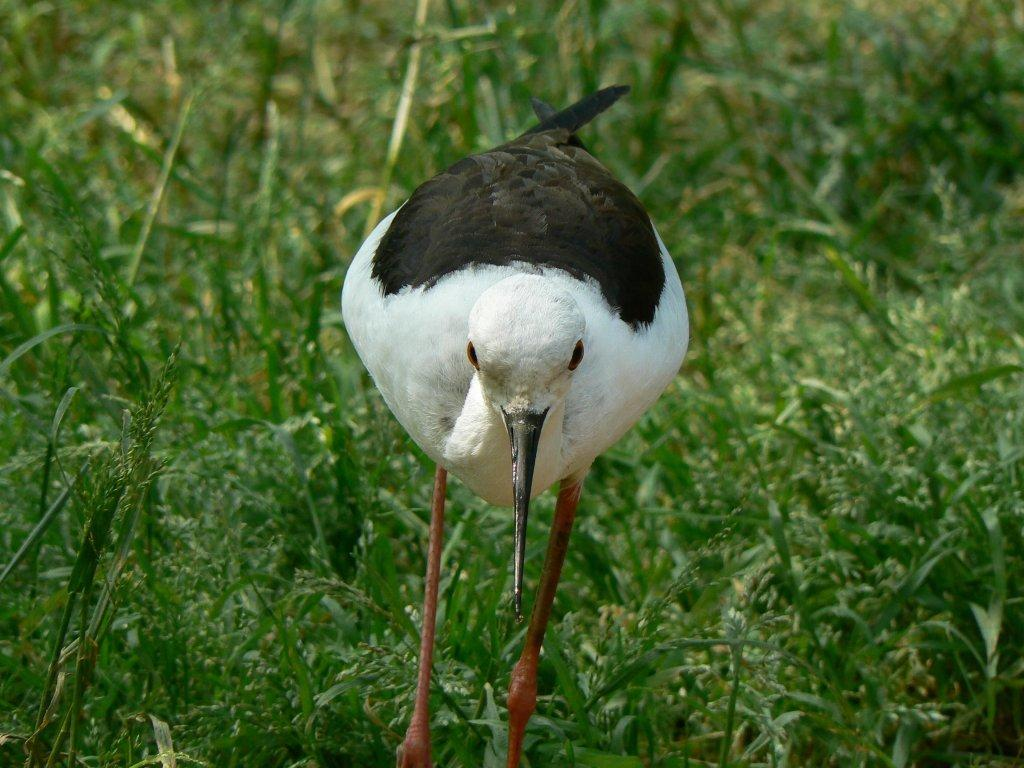What type of animal can be seen in the image? There is a bird in the image. Where is the bird located in the image? The bird is standing on the grass. What color is the grass in the image? The grass in the image is green. What type of bean is the bird holding in its beak in the image? There is no bean present in the image; the bird is standing on the grass. 